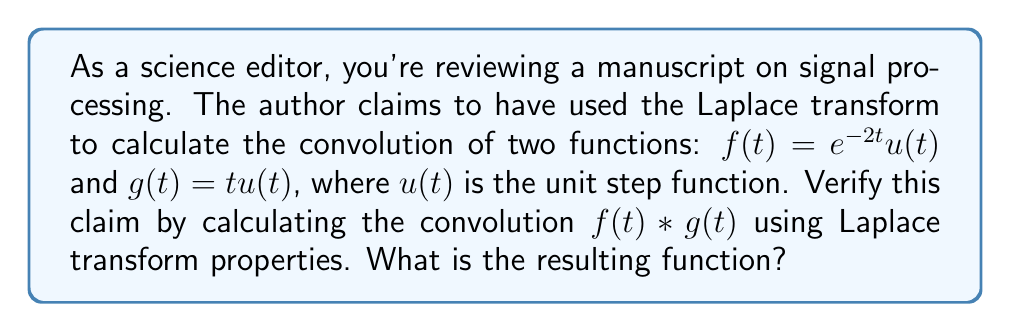What is the answer to this math problem? Let's approach this step-by-step using Laplace transform properties:

1) First, recall that the Laplace transform of the convolution of two functions is equal to the product of their individual Laplace transforms:

   $$\mathcal{L}\{f(t) * g(t)\} = F(s)G(s)$$

2) Let's find $F(s)$, the Laplace transform of $f(t) = e^{-2t}u(t)$:
   
   $$F(s) = \mathcal{L}\{e^{-2t}u(t)\} = \frac{1}{s+2}$$

3) Now, let's find $G(s)$, the Laplace transform of $g(t) = tu(t)$:
   
   $$G(s) = \mathcal{L}\{tu(t)\} = \frac{1}{s^2}$$

4) The product of these transforms gives us the Laplace transform of the convolution:

   $$F(s)G(s) = \frac{1}{s+2} \cdot \frac{1}{s^2} = \frac{1}{s^2(s+2)}$$

5) To find the inverse Laplace transform, we need to use partial fraction decomposition:

   $$\frac{1}{s^2(s+2)} = \frac{A}{s} + \frac{B}{s^2} + \frac{C}{s+2}$$

6) Solving for $A$, $B$, and $C$:

   $$A = -\frac{1}{4}, B = \frac{1}{4}, C = \frac{1}{4}$$

7) Therefore:

   $$\frac{1}{s^2(s+2)} = -\frac{1}{4s} + \frac{1}{4s^2} + \frac{1}{4(s+2)}$$

8) Now we can take the inverse Laplace transform:

   $$\mathcal{L}^{-1}\{F(s)G(s)\} = -\frac{1}{4} + \frac{1}{4}t + \frac{1}{4}e^{-2t}$$

9) This is the convolution of $f(t)$ and $g(t)$. Note that this result is valid for $t \geq 0$ due to the unit step functions in the original functions.
Answer: $f(t) * g(t) = (-\frac{1}{4} + \frac{1}{4}t + \frac{1}{4}e^{-2t})u(t)$ 